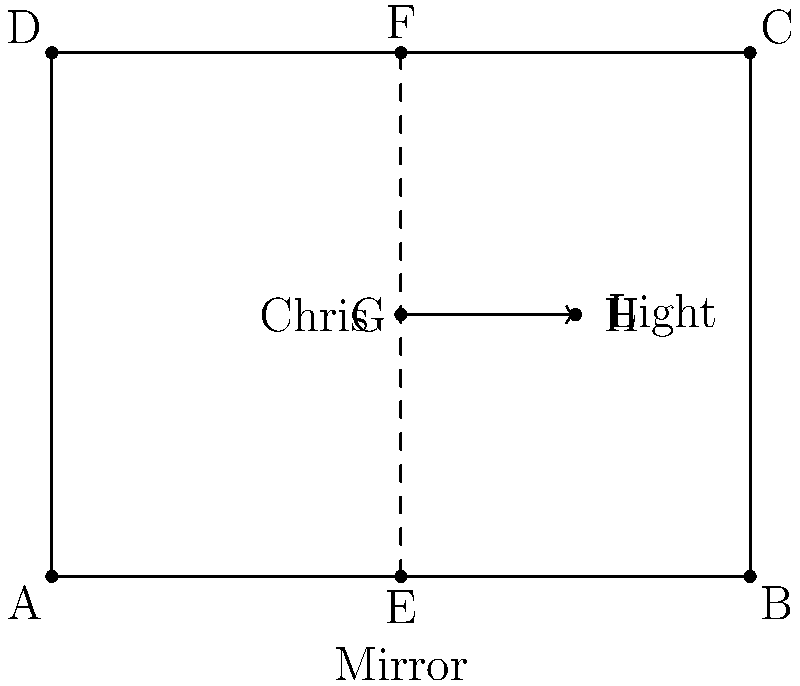In Chris Brown's music studio, a mirror is set up as shown in the diagram. A light beam originating from point G travels horizontally and hits the mirror at point E. If the mirror is 3 meters tall and 4 meters wide, at what angle (in degrees) will the reflected light beam hit the ceiling? Let's approach this step-by-step:

1) First, we need to recognize that the angle of incidence equals the angle of reflection. This is a fundamental law of reflection.

2) The incident beam is horizontal, so it forms a 90° angle with the vertical line from E to F.

3) The angle of incidence (and reflection) is therefore:
   $90° - 90° = 0°$

4) Now, we need to find the angle between the reflected beam and the ceiling. This angle will be the same as the angle between the mirror and the ceiling.

5) We can find this angle using the dimensions of the mirror:
   - Width = 4 meters
   - Height = 3 meters

6) We can use the arctangent function to find this angle:
   $\theta = \arctan(\frac{\text{opposite}}{\text{adjacent}}) = \arctan(\frac{3}{4})$

7) Calculate:
   $\theta = \arctan(\frac{3}{4}) \approx 36.87°$

8) The angle we're looking for is the complement of this angle:
   $90° - 36.87° = 53.13°$

Therefore, the reflected light beam will hit the ceiling at an angle of approximately 53.13°.
Answer: 53.13° 